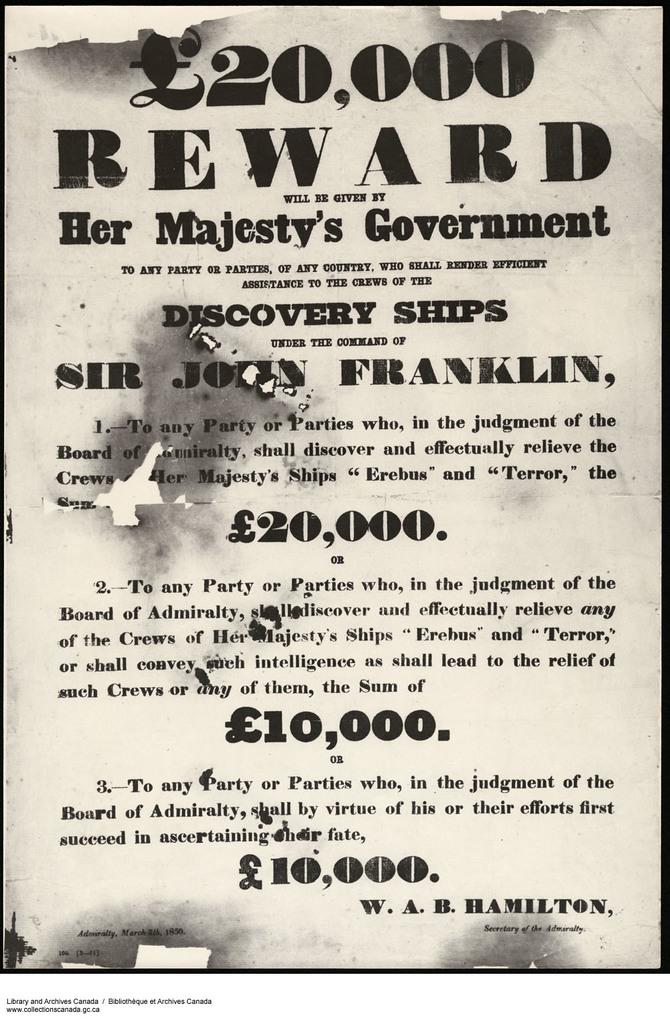<image>
Give a short and clear explanation of the subsequent image. A reward poster to remove the crews of several ships. 